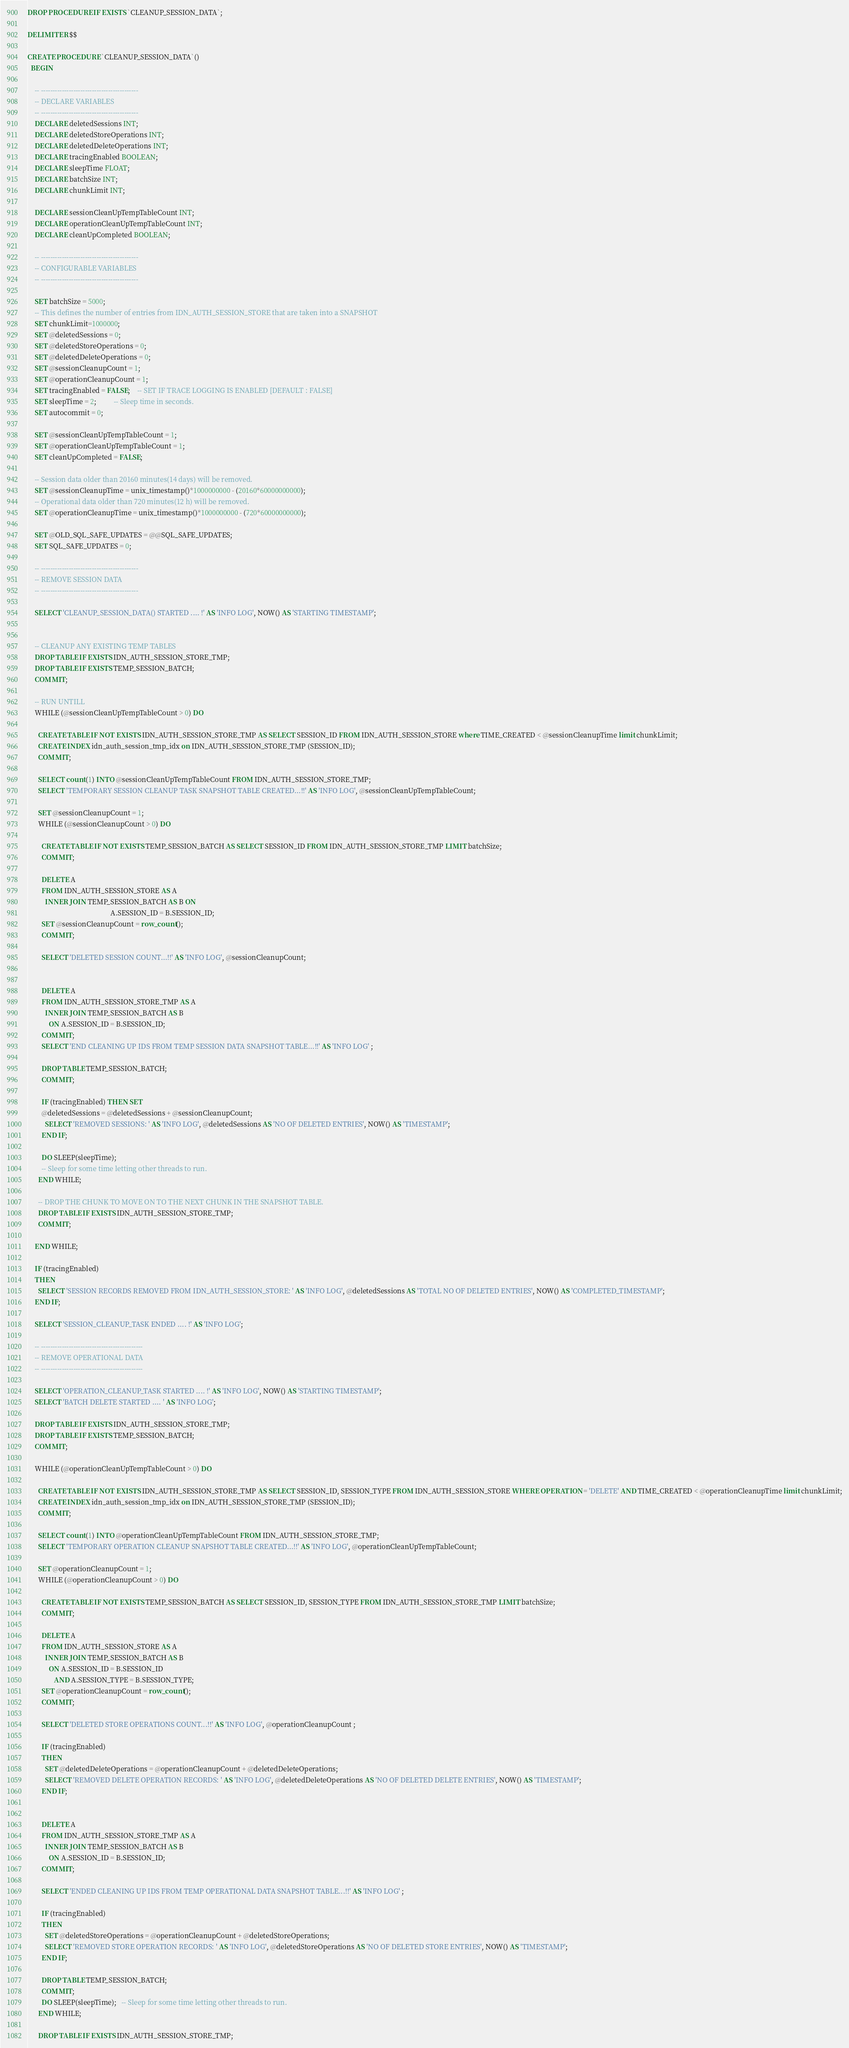Convert code to text. <code><loc_0><loc_0><loc_500><loc_500><_SQL_>DROP PROCEDURE IF EXISTS `CLEANUP_SESSION_DATA`;

DELIMITER $$

CREATE PROCEDURE `CLEANUP_SESSION_DATA`()
  BEGIN

    -- ------------------------------------------
    -- DECLARE VARIABLES
    -- ------------------------------------------
    DECLARE deletedSessions INT;
    DECLARE deletedStoreOperations INT;
    DECLARE deletedDeleteOperations INT;
    DECLARE tracingEnabled BOOLEAN;
    DECLARE sleepTime FLOAT;
    DECLARE batchSize INT;
    DECLARE chunkLimit INT;

    DECLARE sessionCleanUpTempTableCount INT;
    DECLARE operationCleanUpTempTableCount INT;
    DECLARE cleanUpCompleted BOOLEAN;

    -- ------------------------------------------
    -- CONFIGURABLE VARIABLES
    -- ------------------------------------------

    SET batchSize = 5000;
    -- This defines the number of entries from IDN_AUTH_SESSION_STORE that are taken into a SNAPSHOT
    SET chunkLimit=1000000;
    SET @deletedSessions = 0;
    SET @deletedStoreOperations = 0;
    SET @deletedDeleteOperations = 0;
    SET @sessionCleanupCount = 1;
    SET @operationCleanupCount = 1;
    SET tracingEnabled = FALSE;	-- SET IF TRACE LOGGING IS ENABLED [DEFAULT : FALSE]
    SET sleepTime = 2;          -- Sleep time in seconds.
    SET autocommit = 0;

    SET @sessionCleanUpTempTableCount = 1;
    SET @operationCleanUpTempTableCount = 1;
    SET cleanUpCompleted = FALSE;

    -- Session data older than 20160 minutes(14 days) will be removed.
    SET @sessionCleanupTime = unix_timestamp()*1000000000 - (20160*60000000000);
    -- Operational data older than 720 minutes(12 h) will be removed.
    SET @operationCleanupTime = unix_timestamp()*1000000000 - (720*60000000000);

    SET @OLD_SQL_SAFE_UPDATES = @@SQL_SAFE_UPDATES;
    SET SQL_SAFE_UPDATES = 0;

    -- ------------------------------------------
    -- REMOVE SESSION DATA
    -- ------------------------------------------

    SELECT 'CLEANUP_SESSION_DATA() STARTED .... !' AS 'INFO LOG', NOW() AS 'STARTING TIMESTAMP';


    -- CLEANUP ANY EXISTING TEMP TABLES
    DROP TABLE IF EXISTS IDN_AUTH_SESSION_STORE_TMP;
    DROP TABLE IF EXISTS TEMP_SESSION_BATCH;
    COMMIT;

    -- RUN UNTILL
    WHILE (@sessionCleanUpTempTableCount > 0) DO

      CREATE TABLE IF NOT EXISTS IDN_AUTH_SESSION_STORE_TMP AS SELECT SESSION_ID FROM IDN_AUTH_SESSION_STORE where TIME_CREATED < @sessionCleanupTime limit chunkLimit;
      CREATE INDEX idn_auth_session_tmp_idx on IDN_AUTH_SESSION_STORE_TMP (SESSION_ID);
      COMMIT;

      SELECT count(1) INTO @sessionCleanUpTempTableCount FROM IDN_AUTH_SESSION_STORE_TMP;
      SELECT 'TEMPORARY SESSION CLEANUP TASK SNAPSHOT TABLE CREATED...!!' AS 'INFO LOG', @sessionCleanUpTempTableCount;

      SET @sessionCleanupCount = 1;
      WHILE (@sessionCleanupCount > 0) DO

        CREATE TABLE IF NOT EXISTS TEMP_SESSION_BATCH AS SELECT SESSION_ID FROM IDN_AUTH_SESSION_STORE_TMP LIMIT batchSize;
        COMMIT;

        DELETE A
        FROM IDN_AUTH_SESSION_STORE AS A
          INNER JOIN TEMP_SESSION_BATCH AS B ON
                                               A.SESSION_ID = B.SESSION_ID;
        SET @sessionCleanupCount = row_count();
        COMMIT;

        SELECT 'DELETED SESSION COUNT...!!' AS 'INFO LOG', @sessionCleanupCount;


        DELETE A
        FROM IDN_AUTH_SESSION_STORE_TMP AS A
          INNER JOIN TEMP_SESSION_BATCH AS B
            ON A.SESSION_ID = B.SESSION_ID;
        COMMIT;
        SELECT 'END CLEANING UP IDS FROM TEMP SESSION DATA SNAPSHOT TABLE...!!' AS 'INFO LOG' ;

        DROP TABLE TEMP_SESSION_BATCH;
        COMMIT;

        IF (tracingEnabled) THEN SET
        @deletedSessions = @deletedSessions + @sessionCleanupCount;
          SELECT 'REMOVED SESSIONS: ' AS 'INFO LOG', @deletedSessions AS 'NO OF DELETED ENTRIES', NOW() AS 'TIMESTAMP';
        END IF;

        DO SLEEP(sleepTime);
        -- Sleep for some time letting other threads to run.
      END WHILE;

      -- DROP THE CHUNK TO MOVE ON TO THE NEXT CHUNK IN THE SNAPSHOT TABLE.
      DROP TABLE IF EXISTS IDN_AUTH_SESSION_STORE_TMP;
      COMMIT;

    END WHILE;

    IF (tracingEnabled)
    THEN
      SELECT 'SESSION RECORDS REMOVED FROM IDN_AUTH_SESSION_STORE: ' AS 'INFO LOG', @deletedSessions AS 'TOTAL NO OF DELETED ENTRIES', NOW() AS 'COMPLETED_TIMESTAMP';
    END IF;

    SELECT 'SESSION_CLEANUP_TASK ENDED .... !' AS 'INFO LOG';

    -- --------------------------------------------
    -- REMOVE OPERATIONAL DATA
    -- --------------------------------------------

    SELECT 'OPERATION_CLEANUP_TASK STARTED .... !' AS 'INFO LOG', NOW() AS 'STARTING TIMESTAMP';
    SELECT 'BATCH DELETE STARTED .... ' AS 'INFO LOG';

    DROP TABLE IF EXISTS IDN_AUTH_SESSION_STORE_TMP;
    DROP TABLE IF EXISTS TEMP_SESSION_BATCH;
    COMMIT;

    WHILE (@operationCleanUpTempTableCount > 0) DO

      CREATE TABLE IF NOT EXISTS IDN_AUTH_SESSION_STORE_TMP AS SELECT SESSION_ID, SESSION_TYPE FROM IDN_AUTH_SESSION_STORE WHERE OPERATION = 'DELETE' AND TIME_CREATED < @operationCleanupTime limit chunkLimit;
      CREATE INDEX idn_auth_session_tmp_idx on IDN_AUTH_SESSION_STORE_TMP (SESSION_ID);
      COMMIT;

      SELECT count(1) INTO @operationCleanUpTempTableCount FROM IDN_AUTH_SESSION_STORE_TMP;
      SELECT 'TEMPORARY OPERATION CLEANUP SNAPSHOT TABLE CREATED...!!' AS 'INFO LOG', @operationCleanUpTempTableCount;

      SET @operationCleanupCount = 1;
      WHILE (@operationCleanupCount > 0) DO

        CREATE TABLE IF NOT EXISTS TEMP_SESSION_BATCH AS SELECT SESSION_ID, SESSION_TYPE FROM IDN_AUTH_SESSION_STORE_TMP LIMIT batchSize;
        COMMIT;

        DELETE A
        FROM IDN_AUTH_SESSION_STORE AS A
          INNER JOIN TEMP_SESSION_BATCH AS B
            ON A.SESSION_ID = B.SESSION_ID
               AND A.SESSION_TYPE = B.SESSION_TYPE;
        SET @operationCleanupCount = row_count();
        COMMIT;

        SELECT 'DELETED STORE OPERATIONS COUNT...!!' AS 'INFO LOG', @operationCleanupCount ;

        IF (tracingEnabled)
        THEN
          SET @deletedDeleteOperations = @operationCleanupCount + @deletedDeleteOperations;
          SELECT 'REMOVED DELETE OPERATION RECORDS: ' AS 'INFO LOG', @deletedDeleteOperations AS 'NO OF DELETED DELETE ENTRIES', NOW() AS 'TIMESTAMP';
        END IF;


        DELETE A
        FROM IDN_AUTH_SESSION_STORE_TMP AS A
          INNER JOIN TEMP_SESSION_BATCH AS B
            ON A.SESSION_ID = B.SESSION_ID;
        COMMIT;

        SELECT 'ENDED CLEANING UP IDS FROM TEMP OPERATIONAL DATA SNAPSHOT TABLE...!!' AS 'INFO LOG' ;

        IF (tracingEnabled)
        THEN
          SET @deletedStoreOperations = @operationCleanupCount + @deletedStoreOperations;
          SELECT 'REMOVED STORE OPERATION RECORDS: ' AS 'INFO LOG', @deletedStoreOperations AS 'NO OF DELETED STORE ENTRIES', NOW() AS 'TIMESTAMP';
        END IF;

        DROP TABLE TEMP_SESSION_BATCH;
        COMMIT;
        DO SLEEP(sleepTime);   -- Sleep for some time letting other threads to run.
      END WHILE;

      DROP TABLE IF EXISTS IDN_AUTH_SESSION_STORE_TMP;</code> 